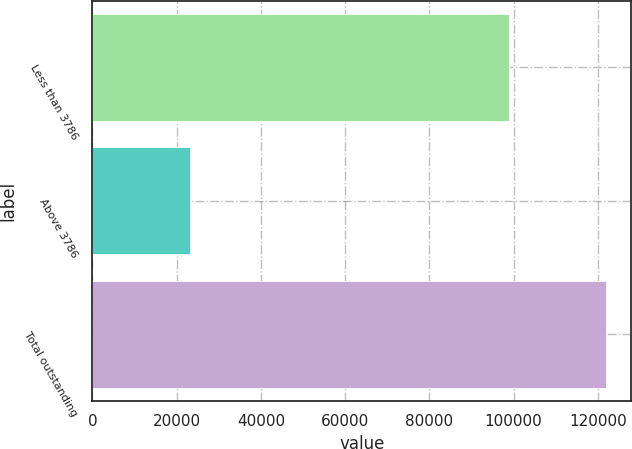Convert chart to OTSL. <chart><loc_0><loc_0><loc_500><loc_500><bar_chart><fcel>Less than 3786<fcel>Above 3786<fcel>Total outstanding<nl><fcel>98804<fcel>23068<fcel>121872<nl></chart> 